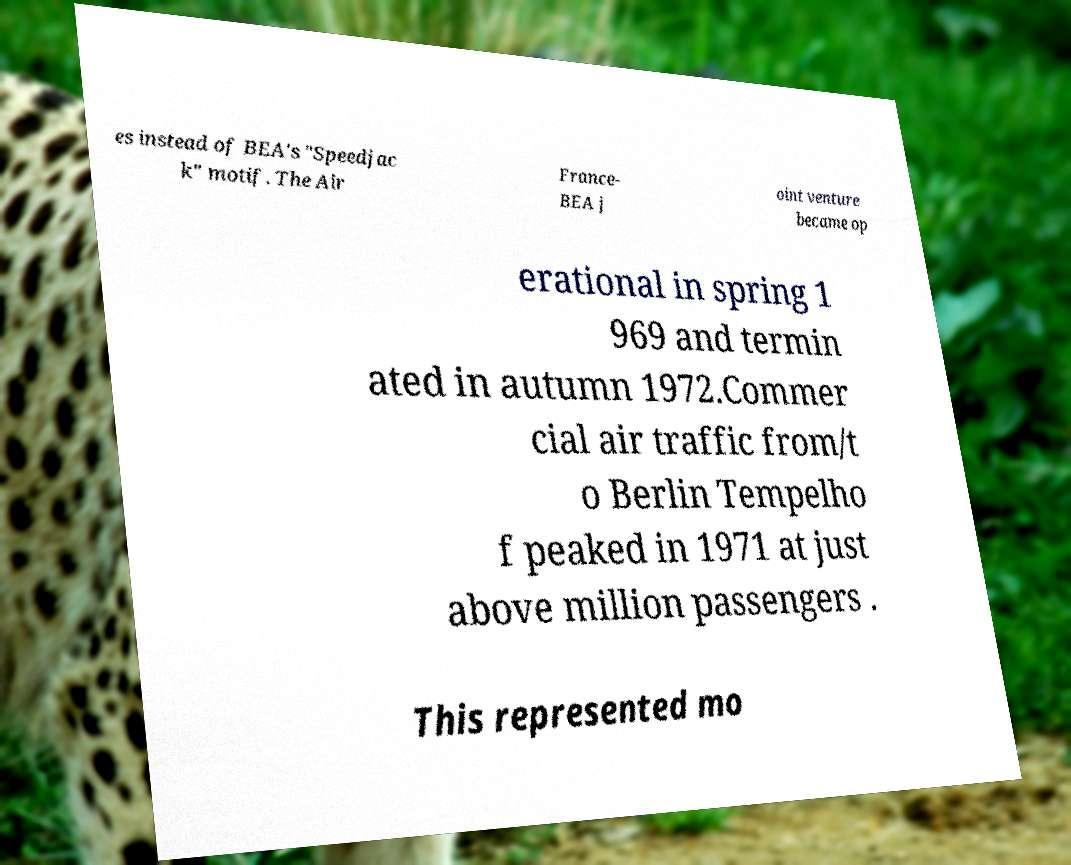What messages or text are displayed in this image? I need them in a readable, typed format. es instead of BEA's "Speedjac k" motif. The Air France- BEA j oint venture became op erational in spring 1 969 and termin ated in autumn 1972.Commer cial air traffic from/t o Berlin Tempelho f peaked in 1971 at just above million passengers . This represented mo 